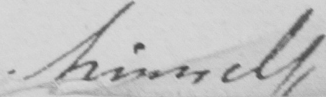Please provide the text content of this handwritten line. himself 